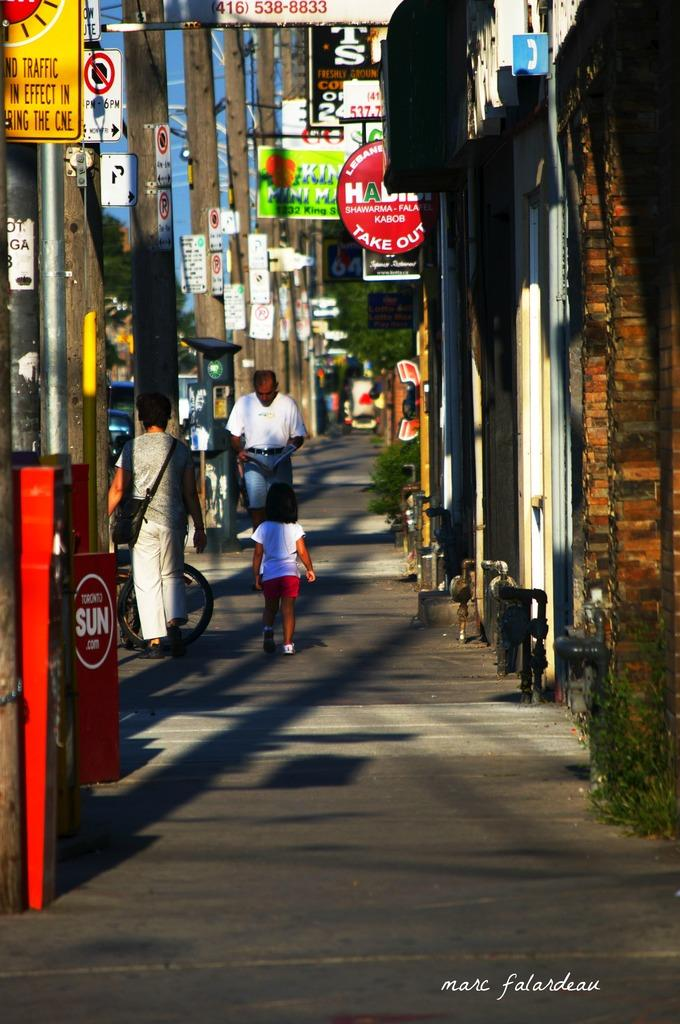<image>
Render a clear and concise summary of the photo. Several people walk down a Toronto street, passing takeout restaurants and other stores. 